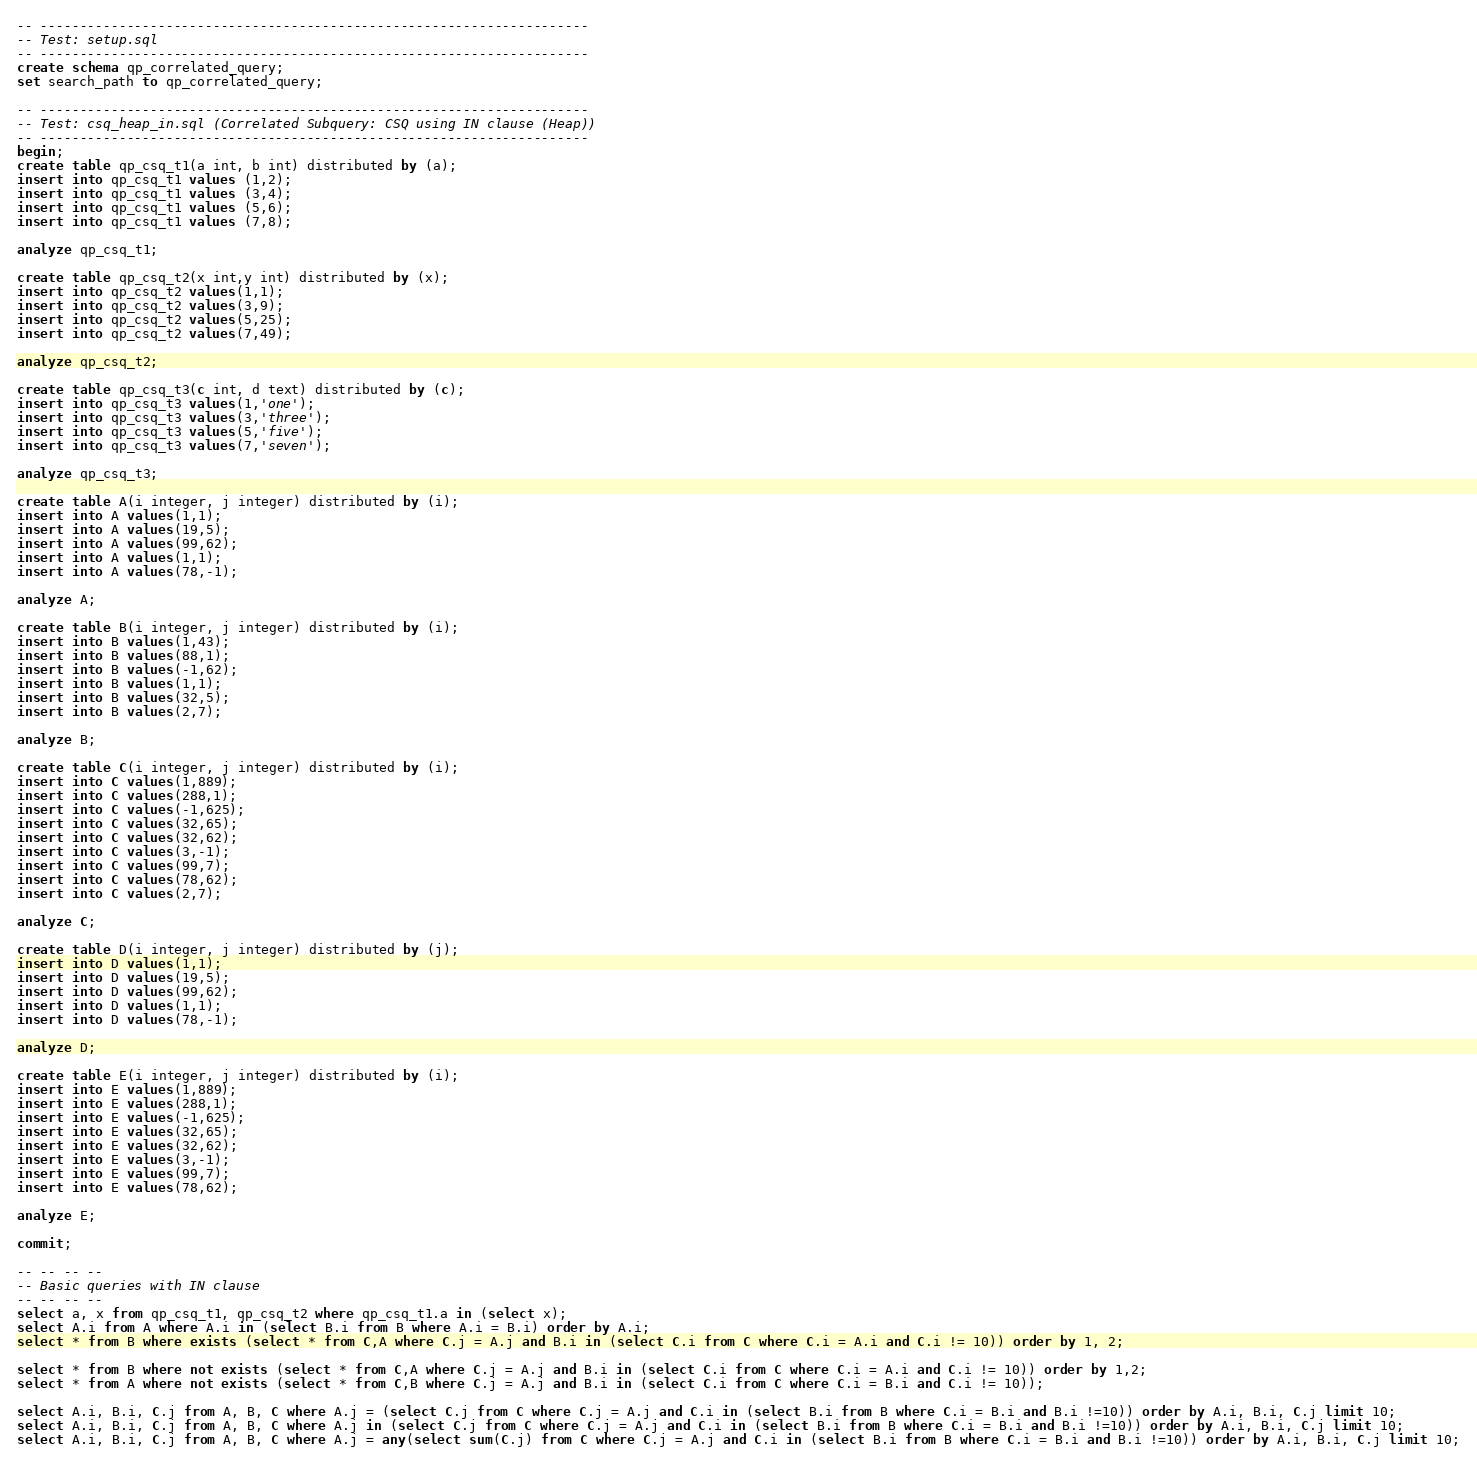Convert code to text. <code><loc_0><loc_0><loc_500><loc_500><_SQL_>-- ----------------------------------------------------------------------
-- Test: setup.sql
-- ----------------------------------------------------------------------
create schema qp_correlated_query;
set search_path to qp_correlated_query;

-- ----------------------------------------------------------------------
-- Test: csq_heap_in.sql (Correlated Subquery: CSQ using IN clause (Heap))
-- ----------------------------------------------------------------------
begin;
create table qp_csq_t1(a int, b int) distributed by (a);
insert into qp_csq_t1 values (1,2);
insert into qp_csq_t1 values (3,4);
insert into qp_csq_t1 values (5,6);
insert into qp_csq_t1 values (7,8);

analyze qp_csq_t1;

create table qp_csq_t2(x int,y int) distributed by (x);
insert into qp_csq_t2 values(1,1);
insert into qp_csq_t2 values(3,9);
insert into qp_csq_t2 values(5,25);
insert into qp_csq_t2 values(7,49);

analyze qp_csq_t2;

create table qp_csq_t3(c int, d text) distributed by (c);
insert into qp_csq_t3 values(1,'one');
insert into qp_csq_t3 values(3,'three');
insert into qp_csq_t3 values(5,'five');
insert into qp_csq_t3 values(7,'seven');

analyze qp_csq_t3;

create table A(i integer, j integer) distributed by (i);
insert into A values(1,1);
insert into A values(19,5);
insert into A values(99,62);
insert into A values(1,1);
insert into A values(78,-1);

analyze A;

create table B(i integer, j integer) distributed by (i);
insert into B values(1,43);
insert into B values(88,1);
insert into B values(-1,62);
insert into B values(1,1);
insert into B values(32,5);
insert into B values(2,7);

analyze B;

create table C(i integer, j integer) distributed by (i);
insert into C values(1,889);
insert into C values(288,1);
insert into C values(-1,625);
insert into C values(32,65);
insert into C values(32,62);
insert into C values(3,-1);
insert into C values(99,7);
insert into C values(78,62);
insert into C values(2,7);

analyze C;

create table D(i integer, j integer) distributed by (j);
insert into D values(1,1);
insert into D values(19,5);
insert into D values(99,62);
insert into D values(1,1);
insert into D values(78,-1);

analyze D;

create table E(i integer, j integer) distributed by (i);
insert into E values(1,889);
insert into E values(288,1);
insert into E values(-1,625);
insert into E values(32,65);
insert into E values(32,62);
insert into E values(3,-1);
insert into E values(99,7);
insert into E values(78,62);

analyze E;

commit;

-- -- -- --
-- Basic queries with IN clause
-- -- -- --
select a, x from qp_csq_t1, qp_csq_t2 where qp_csq_t1.a in (select x);
select A.i from A where A.i in (select B.i from B where A.i = B.i) order by A.i;
select * from B where exists (select * from C,A where C.j = A.j and B.i in (select C.i from C where C.i = A.i and C.i != 10)) order by 1, 2;

select * from B where not exists (select * from C,A where C.j = A.j and B.i in (select C.i from C where C.i = A.i and C.i != 10)) order by 1,2;
select * from A where not exists (select * from C,B where C.j = A.j and B.i in (select C.i from C where C.i = B.i and C.i != 10));

select A.i, B.i, C.j from A, B, C where A.j = (select C.j from C where C.j = A.j and C.i in (select B.i from B where C.i = B.i and B.i !=10)) order by A.i, B.i, C.j limit 10; 
select A.i, B.i, C.j from A, B, C where A.j in (select C.j from C where C.j = A.j and C.i in (select B.i from B where C.i = B.i and B.i !=10)) order by A.i, B.i, C.j limit 10; 
select A.i, B.i, C.j from A, B, C where A.j = any(select sum(C.j) from C where C.j = A.j and C.i in (select B.i from B where C.i = B.i and B.i !=10)) order by A.i, B.i, C.j limit 10;</code> 